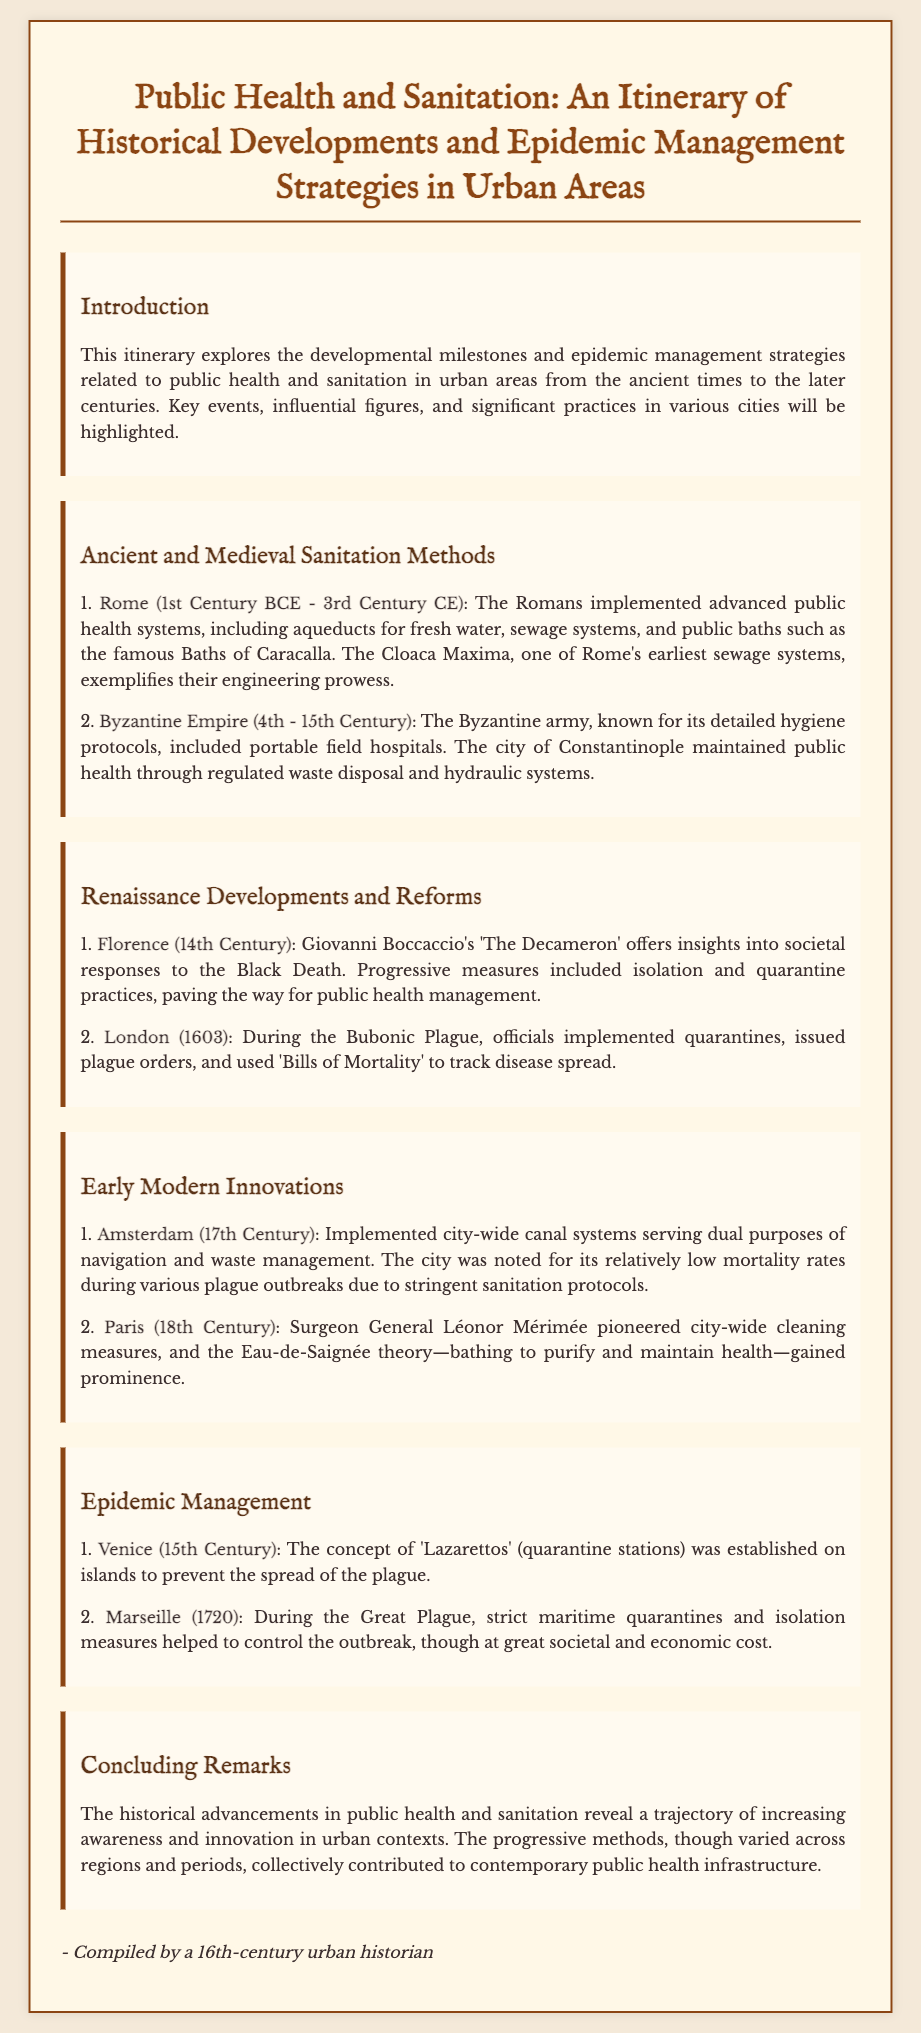What city is known for the implementation of aqueducts and sewage systems in the 1st Century BCE? The document mentions that Rome, during the 1st Century BCE to 3rd Century CE, implemented advanced public health systems, including aqueducts.
Answer: Rome What significant work reflects societal responses to the Black Death? The itinerary states that Giovanni Boccaccio's 'The Decameron' provides insights into the responses during the Black Death in Florence.
Answer: 'The Decameron' In what century were Lazarettos established in Venice? The document notes that the concept of Lazarettos was established in the 15th Century to prevent the spread of plague.
Answer: 15th Century What were the sanitation measures used in Amsterdam during the 17th century? According to the itinerary, Amsterdam implemented city-wide canal systems for both navigation and waste management during the 17th Century.
Answer: Canal systems Which city had significant public health reform initiated by surgeon general Léonor Mérimée? The document highlights Paris in the 18th Century, where Léonor Mérimée pioneered city-wide cleaning measures.
Answer: Paris What was the primary focus of public health strategies during the Great Plague in Marseille? The document states that strict maritime quarantines and isolation measures were the focus in Marseille during the Great Plague in 1720.
Answer: Quarantines What was one of the main epidemic management strategies in London in 1603? The itinerary mentions that during the Bubonic Plague, officials implemented quarantines and used 'Bills of Mortality' in London.
Answer: Quarantines What term refers to the hydraulic systems maintained in Constantinople? The document describes that the Byzantine Empire maintained public health through regulated waste disposal and hydraulic systems in Constantinople.
Answer: Hydraulic systems What does the introductory section of the itinerary highlight? The introduction outlines the developmental milestones and epidemic management strategies related to public health and sanitation in urban areas.
Answer: Developmental milestones 